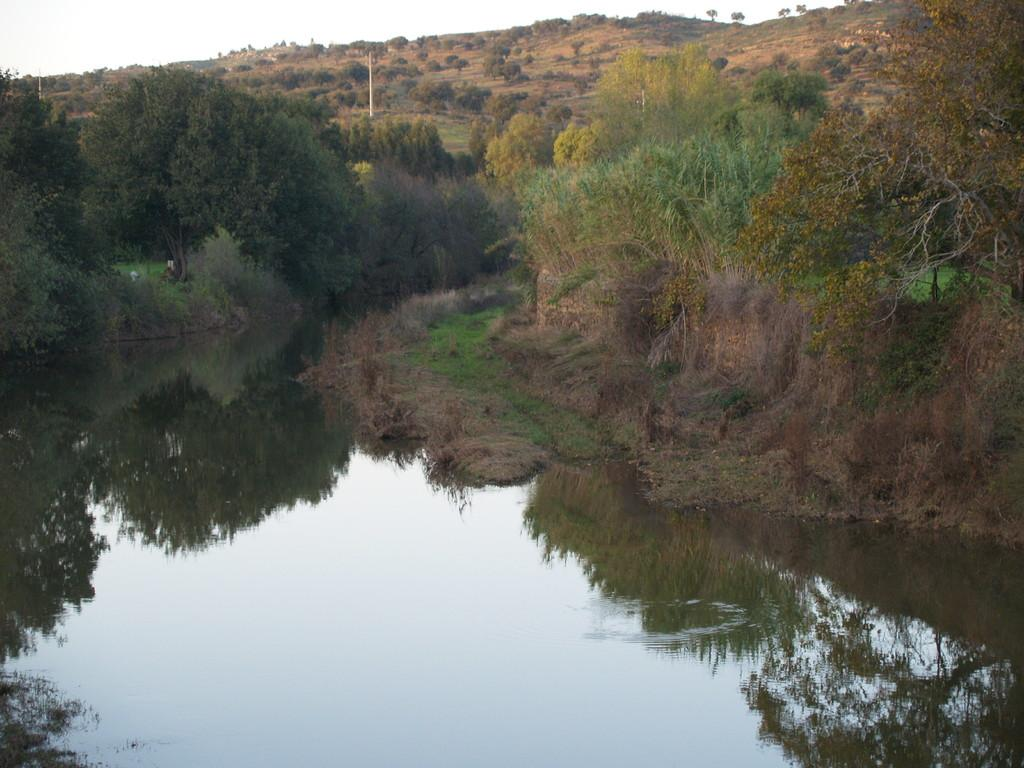What type of body of water is present in the image? There is a pond with water in the image. What type of vegetation can be seen in the image? There are trees with branches and leaves in the image. What geographical feature is visible at the top of the image? There is a hill visible at the top of the image. What type of furniture can be seen in the image? There is no furniture present in the image; it features a pond, trees, and a hill. How many clocks are visible in the image? There are no clocks present in the image. 